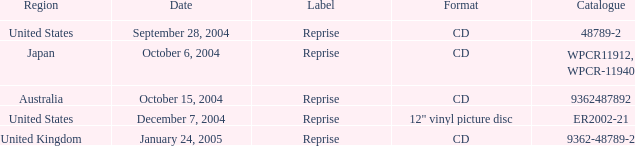Identify the catalog published on october 15, 2004. 9362487892.0. 